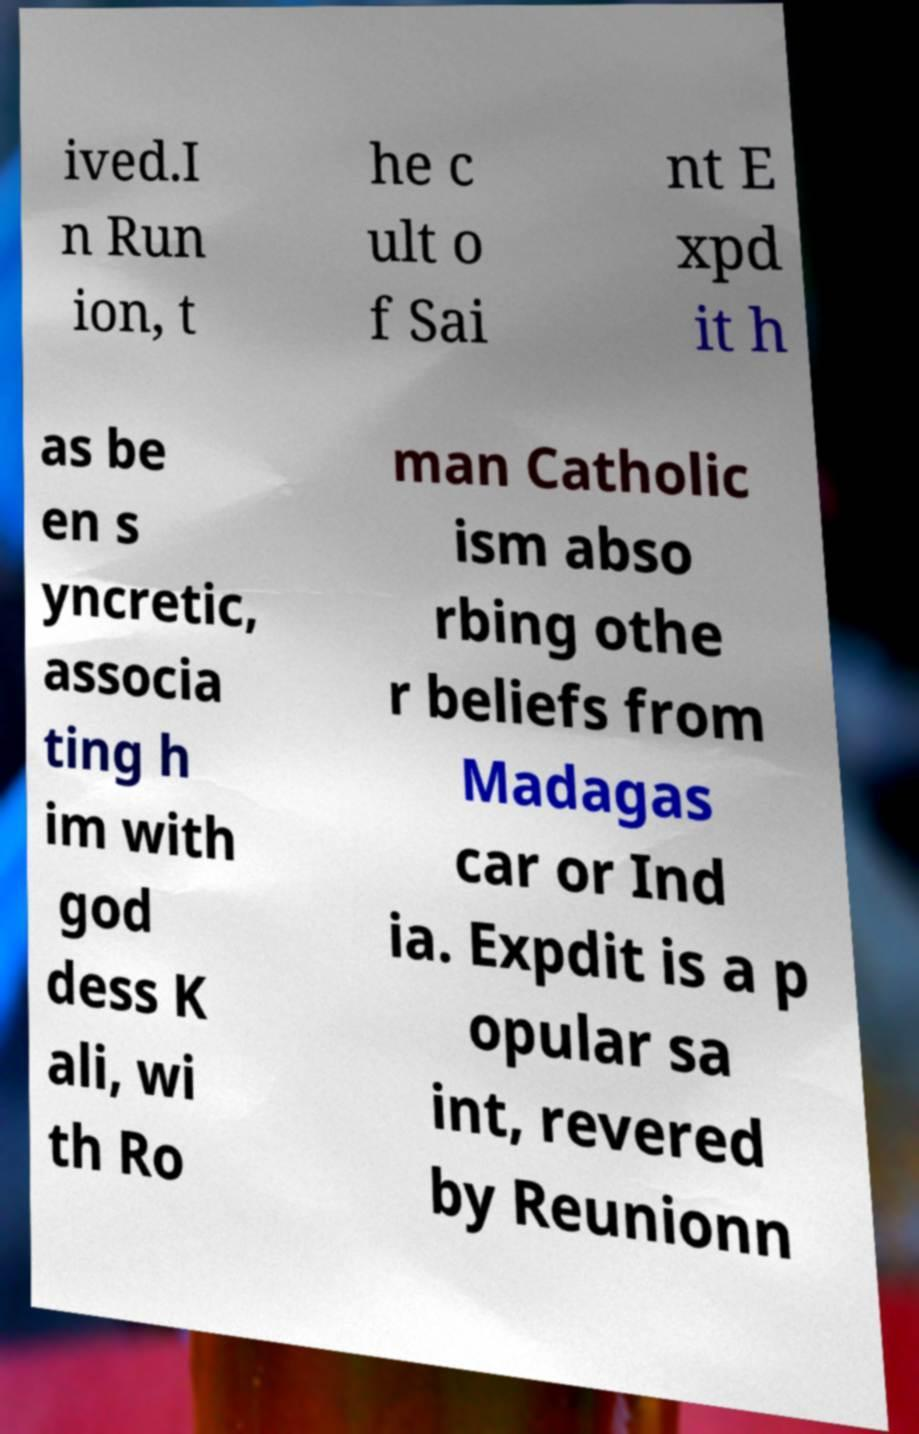Can you accurately transcribe the text from the provided image for me? ived.I n Run ion, t he c ult o f Sai nt E xpd it h as be en s yncretic, associa ting h im with god dess K ali, wi th Ro man Catholic ism abso rbing othe r beliefs from Madagas car or Ind ia. Expdit is a p opular sa int, revered by Reunionn 